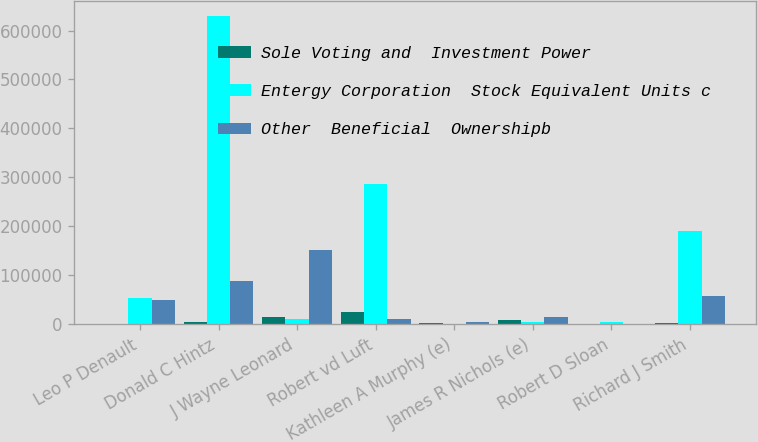<chart> <loc_0><loc_0><loc_500><loc_500><stacked_bar_chart><ecel><fcel>Leo P Denault<fcel>Donald C Hintz<fcel>J Wayne Leonard<fcel>Robert vd Luft<fcel>Kathleen A Murphy (e)<fcel>James R Nichols (e)<fcel>Robert D Sloan<fcel>Richard J Smith<nl><fcel>Sole Voting and  Investment Power<fcel>951<fcel>4963<fcel>13433<fcel>24472<fcel>2700<fcel>8910<fcel>309<fcel>1658<nl><fcel>Entergy Corporation  Stock Equivalent Units c<fcel>52423<fcel>630000<fcel>9600<fcel>285667<fcel>1000<fcel>3684<fcel>4033<fcel>190538<nl><fcel>Other  Beneficial  Ownershipb<fcel>48924<fcel>87605<fcel>150731<fcel>9600<fcel>3200<fcel>14400<fcel>217<fcel>56875<nl></chart> 